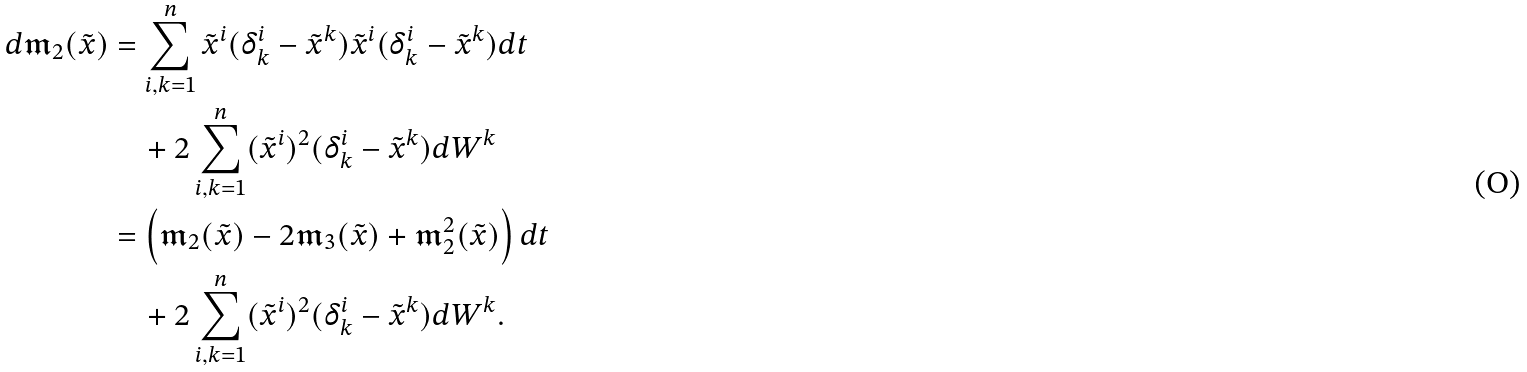<formula> <loc_0><loc_0><loc_500><loc_500>d \mathfrak { m } _ { 2 } ( \tilde { x } ) & = \sum _ { i , k = 1 } ^ { n } \tilde { x } ^ { i } ( \delta _ { k } ^ { i } - \tilde { x } ^ { k } ) \tilde { x } ^ { i } ( \delta _ { k } ^ { i } - \tilde { x } ^ { k } ) d t \\ & \quad + 2 \sum _ { i , k = 1 } ^ { n } ( \tilde { x } ^ { i } ) ^ { 2 } ( \delta _ { k } ^ { i } - \tilde { x } ^ { k } ) d W ^ { k } \\ & = \left ( \mathfrak { m } _ { 2 } ( \tilde { x } ) - 2 \mathfrak { m } _ { 3 } ( \tilde { x } ) + \mathfrak { m } _ { 2 } ^ { 2 } ( \tilde { x } ) \right ) d t \\ & \quad + 2 \sum _ { i , k = 1 } ^ { n } ( \tilde { x } ^ { i } ) ^ { 2 } ( \delta _ { k } ^ { i } - \tilde { x } ^ { k } ) d W ^ { k } .</formula> 